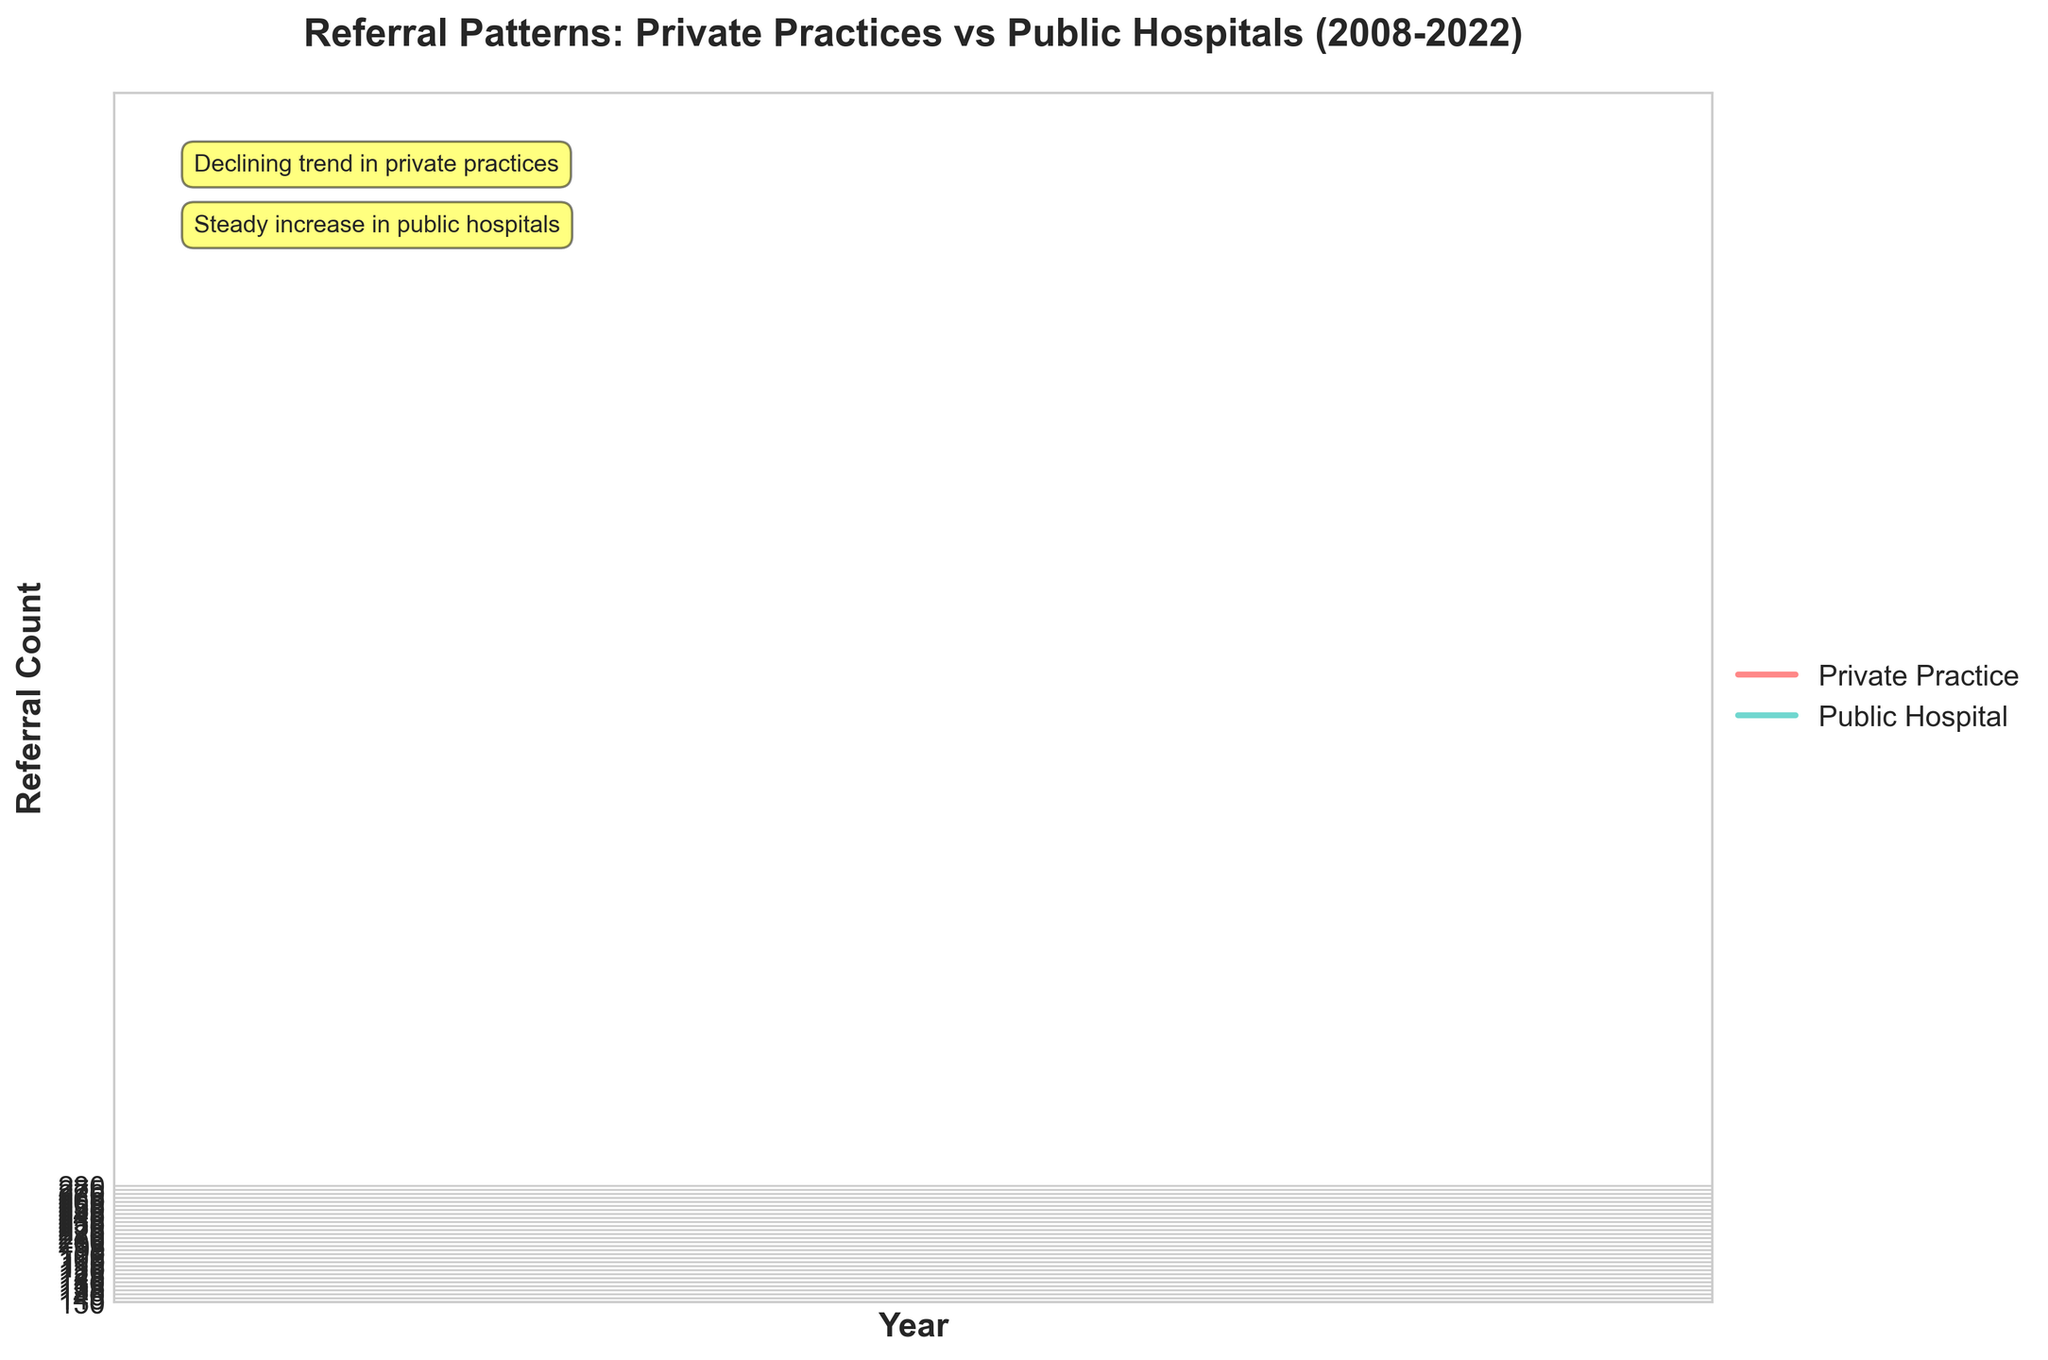How many years of data are displayed in the figure? The x-axis labels the years from 2008 to 2022, providing a total of 15 years of data.
Answer: 15 What are the colors used to differentiate between private practices and public hospitals? The private practices are represented in red, while the public hospitals are shown in green.
Answer: Red and Green What is the trend for referral counts from private practices over the 15 years? The referral counts from private practices show a declining trend from 150 in 2008 to 95 in 2022.
Answer: Declining How do the referral counts in 2008 for private practices compare to public hospitals? In 2008, the referral count for private practices is 150, while for public hospitals it is 200. Public hospitals have a higher count.
Answer: Public hospitals have a higher count by 50 Is there any year where the referral count from private practices increases? The trend line for private practices shows a steady decline every year, with no increase at any point.
Answer: No What is the difference in referral counts between private practices and public hospitals in 2022? The referral count in 2022 for private practices is 95, and for public hospitals it is 280. The difference is 280 - 95 = 185.
Answer: 185 What is the average referral count for private practices over the 15 years displayed? Sum all the referral counts for private practices (150 + 145 + ... + 95) which equals 1734. Then divide by the number of years, 1734 / 15 ≈ 115.6.
Answer: 115.6 Which practice type shows a consistent increase in referral counts over the years? Public hospitals display a consistent increase in referral counts from 2008 to 2022.
Answer: Public hospitals By how much did the referral counts for private practices decrease from 2008 to 2022? The referral counts for private practices decreased from 150 in 2008 to 95 in 2022. The decrease amount is 150 - 95 = 55.
Answer: 55 What kind of annotations are added to the chart? Two annotations highlight the trends: one indicating the "Declining trend in private practices" and another showing the "Steady increase in public hospitals".
Answer: Declining trend in private practices, Steady increase in public hospitals 